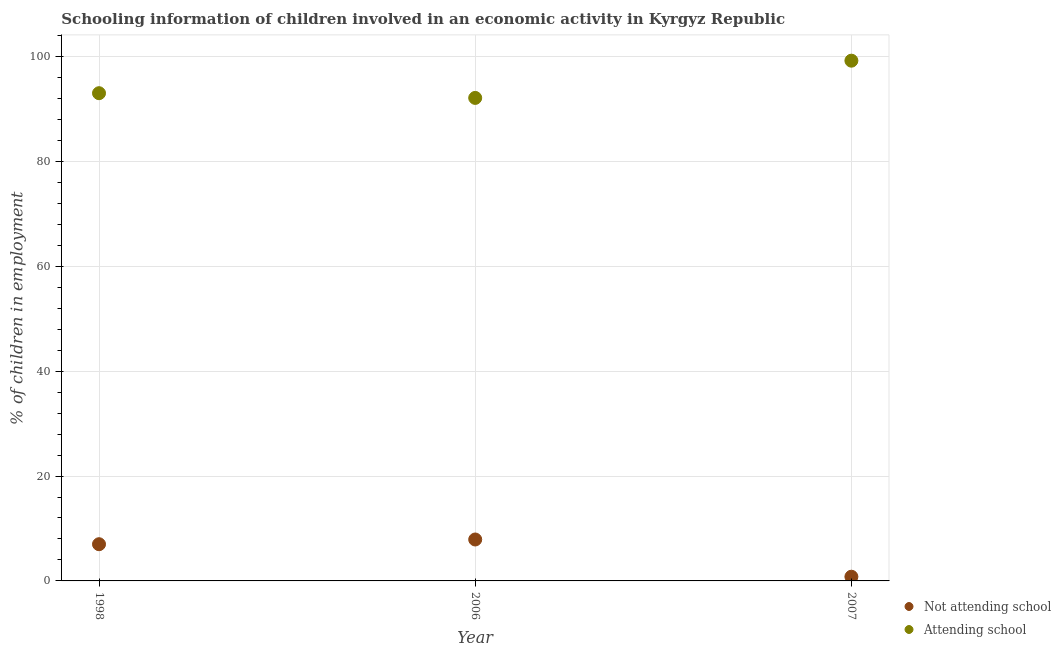How many different coloured dotlines are there?
Keep it short and to the point. 2. Across all years, what is the maximum percentage of employed children who are attending school?
Ensure brevity in your answer.  99.2. Across all years, what is the minimum percentage of employed children who are not attending school?
Offer a terse response. 0.8. What is the total percentage of employed children who are attending school in the graph?
Your answer should be compact. 284.3. What is the difference between the percentage of employed children who are attending school in 2006 and the percentage of employed children who are not attending school in 1998?
Provide a succinct answer. 85.1. What is the average percentage of employed children who are not attending school per year?
Keep it short and to the point. 5.23. In the year 2006, what is the difference between the percentage of employed children who are not attending school and percentage of employed children who are attending school?
Your answer should be compact. -84.2. What is the ratio of the percentage of employed children who are attending school in 1998 to that in 2007?
Make the answer very short. 0.94. Is the difference between the percentage of employed children who are not attending school in 1998 and 2007 greater than the difference between the percentage of employed children who are attending school in 1998 and 2007?
Offer a very short reply. Yes. What is the difference between the highest and the second highest percentage of employed children who are attending school?
Provide a short and direct response. 6.2. What is the difference between the highest and the lowest percentage of employed children who are not attending school?
Ensure brevity in your answer.  7.1. In how many years, is the percentage of employed children who are attending school greater than the average percentage of employed children who are attending school taken over all years?
Your answer should be compact. 1. Is the sum of the percentage of employed children who are attending school in 1998 and 2007 greater than the maximum percentage of employed children who are not attending school across all years?
Provide a short and direct response. Yes. Does the percentage of employed children who are attending school monotonically increase over the years?
Provide a succinct answer. No. Is the percentage of employed children who are attending school strictly less than the percentage of employed children who are not attending school over the years?
Your answer should be compact. No. What is the difference between two consecutive major ticks on the Y-axis?
Your response must be concise. 20. Are the values on the major ticks of Y-axis written in scientific E-notation?
Your answer should be compact. No. Does the graph contain grids?
Offer a terse response. Yes. Where does the legend appear in the graph?
Provide a short and direct response. Bottom right. How many legend labels are there?
Offer a terse response. 2. What is the title of the graph?
Your answer should be very brief. Schooling information of children involved in an economic activity in Kyrgyz Republic. Does "DAC donors" appear as one of the legend labels in the graph?
Your answer should be compact. No. What is the label or title of the Y-axis?
Make the answer very short. % of children in employment. What is the % of children in employment of Attending school in 1998?
Provide a short and direct response. 93. What is the % of children in employment in Not attending school in 2006?
Offer a terse response. 7.9. What is the % of children in employment in Attending school in 2006?
Your response must be concise. 92.1. What is the % of children in employment in Not attending school in 2007?
Your answer should be very brief. 0.8. What is the % of children in employment in Attending school in 2007?
Keep it short and to the point. 99.2. Across all years, what is the maximum % of children in employment of Attending school?
Offer a terse response. 99.2. Across all years, what is the minimum % of children in employment of Not attending school?
Keep it short and to the point. 0.8. Across all years, what is the minimum % of children in employment in Attending school?
Offer a very short reply. 92.1. What is the total % of children in employment of Not attending school in the graph?
Your response must be concise. 15.7. What is the total % of children in employment of Attending school in the graph?
Keep it short and to the point. 284.3. What is the difference between the % of children in employment in Not attending school in 1998 and that in 2006?
Keep it short and to the point. -0.9. What is the difference between the % of children in employment in Not attending school in 2006 and that in 2007?
Provide a succinct answer. 7.1. What is the difference between the % of children in employment of Not attending school in 1998 and the % of children in employment of Attending school in 2006?
Offer a terse response. -85.1. What is the difference between the % of children in employment in Not attending school in 1998 and the % of children in employment in Attending school in 2007?
Keep it short and to the point. -92.2. What is the difference between the % of children in employment of Not attending school in 2006 and the % of children in employment of Attending school in 2007?
Provide a succinct answer. -91.3. What is the average % of children in employment of Not attending school per year?
Your response must be concise. 5.23. What is the average % of children in employment in Attending school per year?
Offer a terse response. 94.77. In the year 1998, what is the difference between the % of children in employment of Not attending school and % of children in employment of Attending school?
Your answer should be compact. -86. In the year 2006, what is the difference between the % of children in employment of Not attending school and % of children in employment of Attending school?
Provide a succinct answer. -84.2. In the year 2007, what is the difference between the % of children in employment in Not attending school and % of children in employment in Attending school?
Your answer should be compact. -98.4. What is the ratio of the % of children in employment of Not attending school in 1998 to that in 2006?
Provide a succinct answer. 0.89. What is the ratio of the % of children in employment in Attending school in 1998 to that in 2006?
Offer a very short reply. 1.01. What is the ratio of the % of children in employment of Not attending school in 1998 to that in 2007?
Offer a very short reply. 8.75. What is the ratio of the % of children in employment of Attending school in 1998 to that in 2007?
Make the answer very short. 0.94. What is the ratio of the % of children in employment in Not attending school in 2006 to that in 2007?
Your answer should be very brief. 9.88. What is the ratio of the % of children in employment of Attending school in 2006 to that in 2007?
Give a very brief answer. 0.93. What is the difference between the highest and the second highest % of children in employment in Not attending school?
Provide a succinct answer. 0.9. What is the difference between the highest and the second highest % of children in employment of Attending school?
Your answer should be compact. 6.2. 